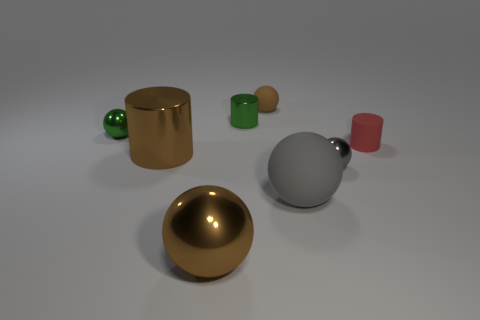What color is the small ball in front of the small red rubber cylinder?
Provide a short and direct response. Gray. There is a large thing that is in front of the gray metallic object and on the left side of the brown rubber thing; what is it made of?
Your answer should be very brief. Metal. There is a gray object that is made of the same material as the green cylinder; what shape is it?
Your response must be concise. Sphere. There is a rubber object behind the small rubber cylinder; how many brown balls are in front of it?
Your response must be concise. 1. What number of small cylinders are both on the left side of the small rubber sphere and in front of the tiny green shiny ball?
Offer a terse response. 0. What number of other things are made of the same material as the green ball?
Your answer should be very brief. 4. There is a cylinder that is in front of the thing to the right of the small gray sphere; what is its color?
Ensure brevity in your answer.  Brown. There is a tiny shiny sphere that is in front of the small red thing; does it have the same color as the large matte ball?
Ensure brevity in your answer.  Yes. Do the brown shiny cylinder and the gray rubber object have the same size?
Your answer should be compact. Yes. What shape is the red thing that is the same size as the gray shiny ball?
Give a very brief answer. Cylinder. 